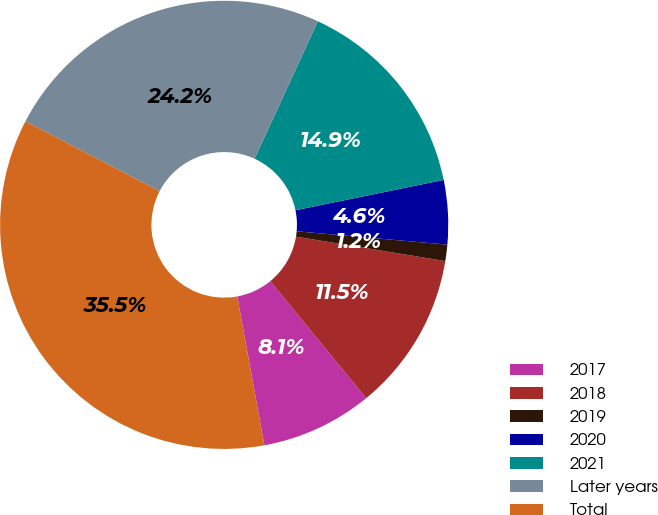Convert chart. <chart><loc_0><loc_0><loc_500><loc_500><pie_chart><fcel>2017<fcel>2018<fcel>2019<fcel>2020<fcel>2021<fcel>Later years<fcel>Total<nl><fcel>8.05%<fcel>11.49%<fcel>1.18%<fcel>4.62%<fcel>14.92%<fcel>24.22%<fcel>35.52%<nl></chart> 